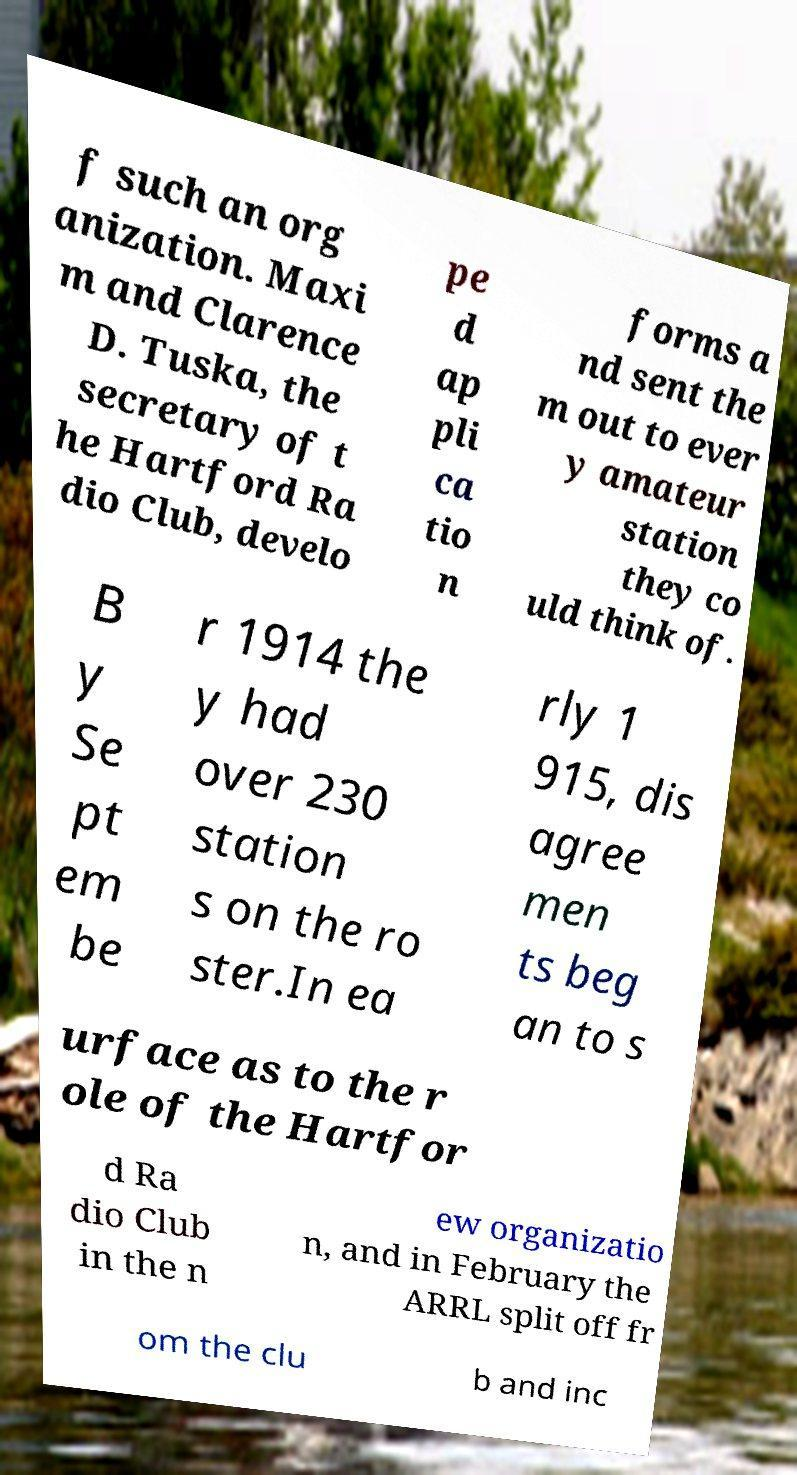I need the written content from this picture converted into text. Can you do that? f such an org anization. Maxi m and Clarence D. Tuska, the secretary of t he Hartford Ra dio Club, develo pe d ap pli ca tio n forms a nd sent the m out to ever y amateur station they co uld think of. B y Se pt em be r 1914 the y had over 230 station s on the ro ster.In ea rly 1 915, dis agree men ts beg an to s urface as to the r ole of the Hartfor d Ra dio Club in the n ew organizatio n, and in February the ARRL split off fr om the clu b and inc 